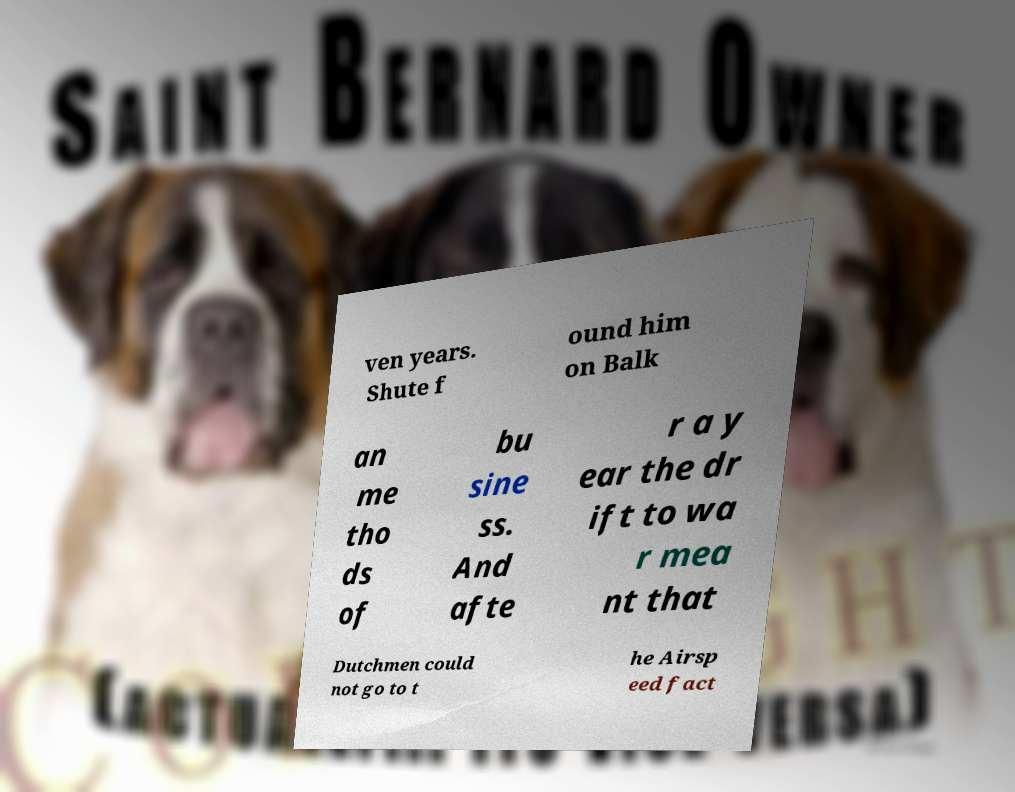Please identify and transcribe the text found in this image. ven years. Shute f ound him on Balk an me tho ds of bu sine ss. And afte r a y ear the dr ift to wa r mea nt that Dutchmen could not go to t he Airsp eed fact 